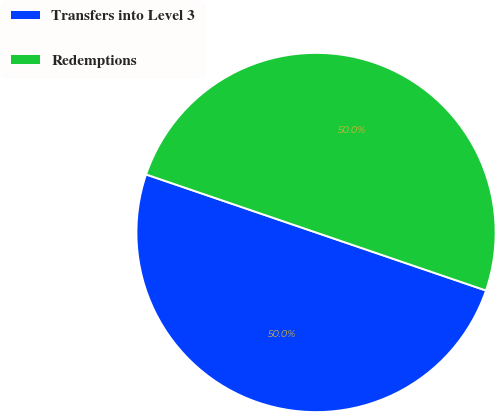Convert chart to OTSL. <chart><loc_0><loc_0><loc_500><loc_500><pie_chart><fcel>Transfers into Level 3<fcel>Redemptions<nl><fcel>50.0%<fcel>50.0%<nl></chart> 